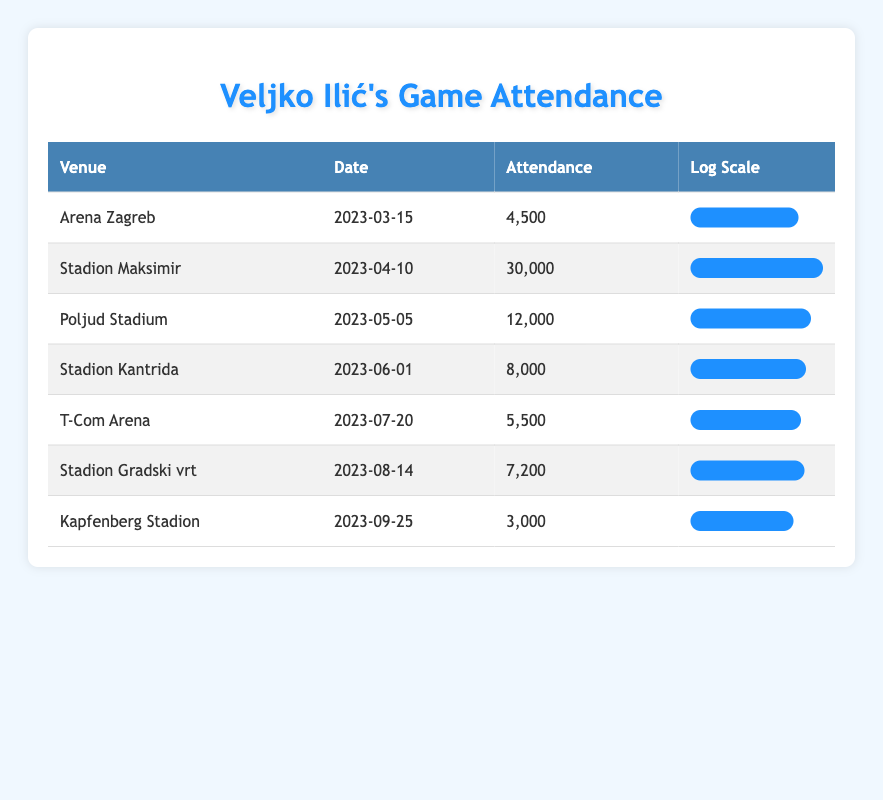What was the highest attendance figure recorded in the table? The highest attendance figure can be found by looking at the "Attendance" column and identifying the maximum value. From the table, the highest figure is 30,000 at "Stadion Maksimir" on "2023-04-10".
Answer: 30,000 Which venue had the lowest attendance? To find the lowest attendance, we can compare all attendance figures in the "Attendance" column. The lowest figure is 3,000, recorded at "Kapfenberg Stadion" on "2023-09-25".
Answer: 3,000 What is the average attendance across all venues? First, we sum all the attendance figures: 4,500 + 30,000 + 12,000 + 8,000 + 5,500 + 7,200 + 3,000 = 70,200. Next, we divide this by the number of venues (7): 70,200 / 7 = 10,028.57 (rounded to 10,029 for report purposes).
Answer: 10,029 Is the attendance at "T-Com Arena" higher than the attendance at "Stadion Kantrida"? Comparing the attendance figures, "T-Com Arena" has an attendance of 5,500 and "Stadion Kantrida" has 8,000. Since 5,500 is less than 8,000, the statement is false.
Answer: No How much greater is the attendance at "Stadion Maksimir" compared to "Kapfenberg Stadion"? We calculate the difference: 30,000 (Stadion Maksimir) - 3,000 (Kapfenberg Stadion) = 27,000. Thus, the attendance at "Stadion Maksimir" is 27,000 greater than that of "Kapfenberg Stadion".
Answer: 27,000 What percentage of the maximum attendance does the attendance at "Poljud Stadium" represent? First, we identify the maximum attendance which is 30,000 at "Stadion Maksimir." Then, we calculate the percentage: (12,000 / 30,000) x 100 = 40%. Thus, the attendance at "Poljud Stadium" represents 40% of the maximum.
Answer: 40% Which venues had an attendance of more than 7,000? By analyzing each venue's attendance figure, the venues with attendance greater than 7,000 are: "Stadion Maksimir" (30,000), "Poljud Stadium" (12,000), "Stadion Kantrida" (8,000), "Stadion Gradski vrt" (7,200). Thus, four venues fall into this category.
Answer: 4 venues What is the total attendance for all games held at the venues listed? We sum the attendance figures: 4,500 + 30,000 + 12,000 + 8,000 + 5,500 + 7,200 + 3,000 = 70,200. Therefore, the total attendance for all games is 70,200.
Answer: 70,200 